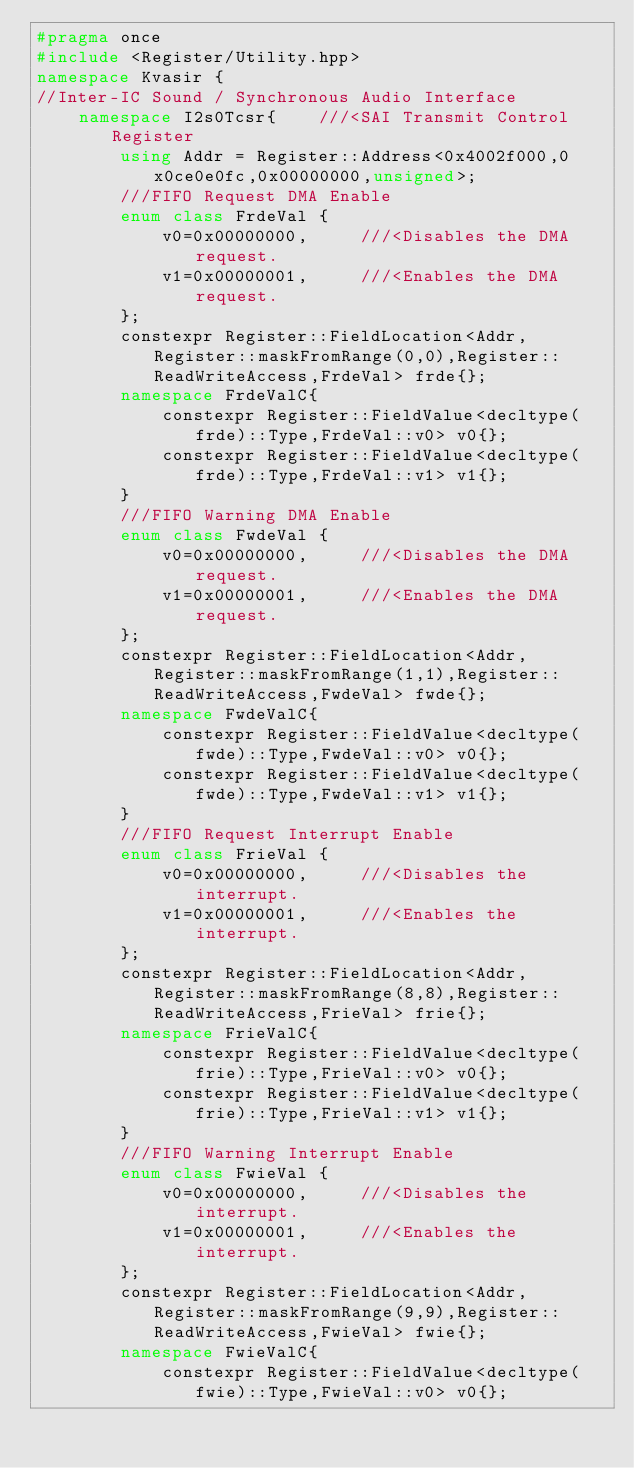<code> <loc_0><loc_0><loc_500><loc_500><_C++_>#pragma once 
#include <Register/Utility.hpp>
namespace Kvasir {
//Inter-IC Sound / Synchronous Audio Interface
    namespace I2s0Tcsr{    ///<SAI Transmit Control Register
        using Addr = Register::Address<0x4002f000,0x0ce0e0fc,0x00000000,unsigned>;
        ///FIFO Request DMA Enable
        enum class FrdeVal {
            v0=0x00000000,     ///<Disables the DMA request.
            v1=0x00000001,     ///<Enables the DMA request.
        };
        constexpr Register::FieldLocation<Addr,Register::maskFromRange(0,0),Register::ReadWriteAccess,FrdeVal> frde{}; 
        namespace FrdeValC{
            constexpr Register::FieldValue<decltype(frde)::Type,FrdeVal::v0> v0{};
            constexpr Register::FieldValue<decltype(frde)::Type,FrdeVal::v1> v1{};
        }
        ///FIFO Warning DMA Enable
        enum class FwdeVal {
            v0=0x00000000,     ///<Disables the DMA request.
            v1=0x00000001,     ///<Enables the DMA request.
        };
        constexpr Register::FieldLocation<Addr,Register::maskFromRange(1,1),Register::ReadWriteAccess,FwdeVal> fwde{}; 
        namespace FwdeValC{
            constexpr Register::FieldValue<decltype(fwde)::Type,FwdeVal::v0> v0{};
            constexpr Register::FieldValue<decltype(fwde)::Type,FwdeVal::v1> v1{};
        }
        ///FIFO Request Interrupt Enable
        enum class FrieVal {
            v0=0x00000000,     ///<Disables the interrupt.
            v1=0x00000001,     ///<Enables the interrupt.
        };
        constexpr Register::FieldLocation<Addr,Register::maskFromRange(8,8),Register::ReadWriteAccess,FrieVal> frie{}; 
        namespace FrieValC{
            constexpr Register::FieldValue<decltype(frie)::Type,FrieVal::v0> v0{};
            constexpr Register::FieldValue<decltype(frie)::Type,FrieVal::v1> v1{};
        }
        ///FIFO Warning Interrupt Enable
        enum class FwieVal {
            v0=0x00000000,     ///<Disables the interrupt.
            v1=0x00000001,     ///<Enables the interrupt.
        };
        constexpr Register::FieldLocation<Addr,Register::maskFromRange(9,9),Register::ReadWriteAccess,FwieVal> fwie{}; 
        namespace FwieValC{
            constexpr Register::FieldValue<decltype(fwie)::Type,FwieVal::v0> v0{};</code> 